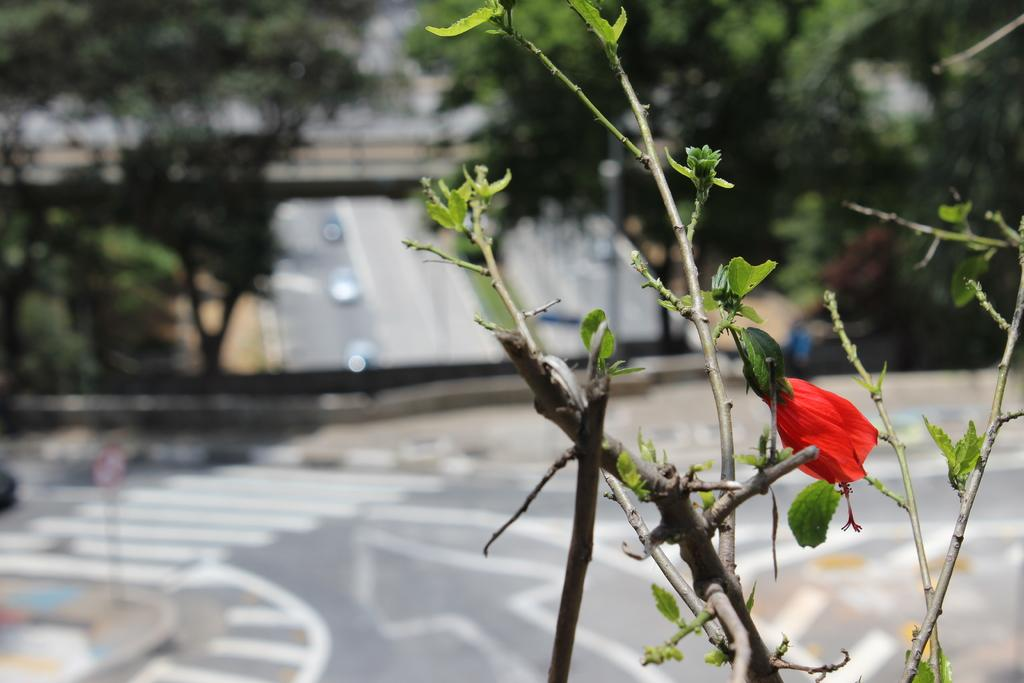What type of plant is in the image? There is a plant in the image with an orange flower. What can be seen in the background of the image? There are trees and buildings in the background of the image. How is the background of the image depicted? The background is blurred. Is the existence of a hill confirmed in the image? There is no hill present in the image. What type of station is visible in the image? There is no station present in the image. 